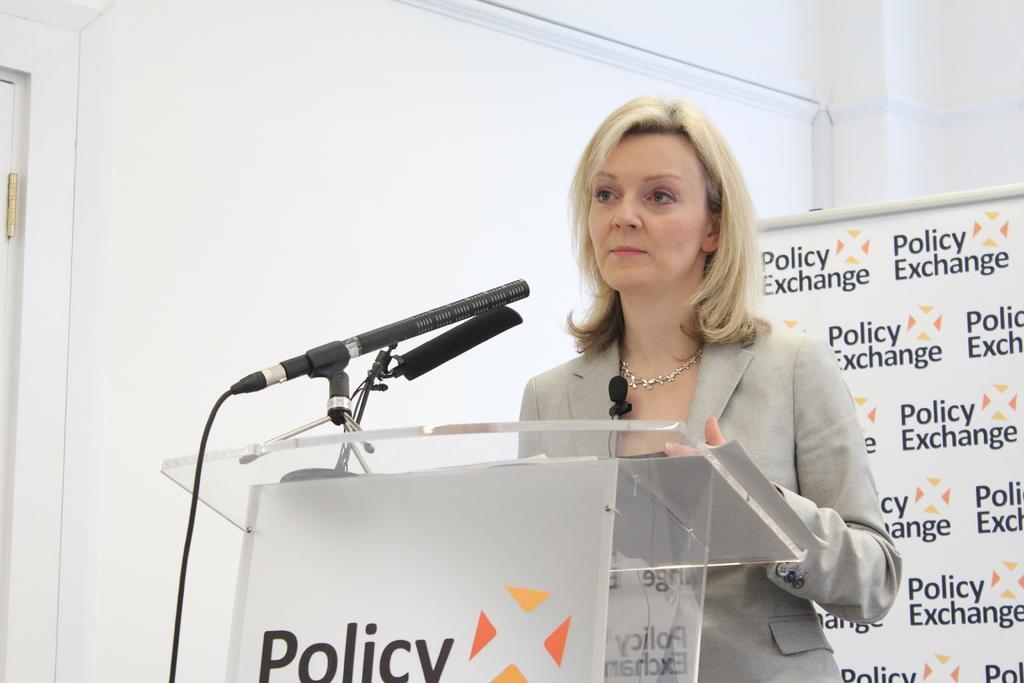How would you summarize this image in a sentence or two? In this picture we can see a woman, in front of her we can see a podium, here we can see mics and in the background we can see a board, wall. 